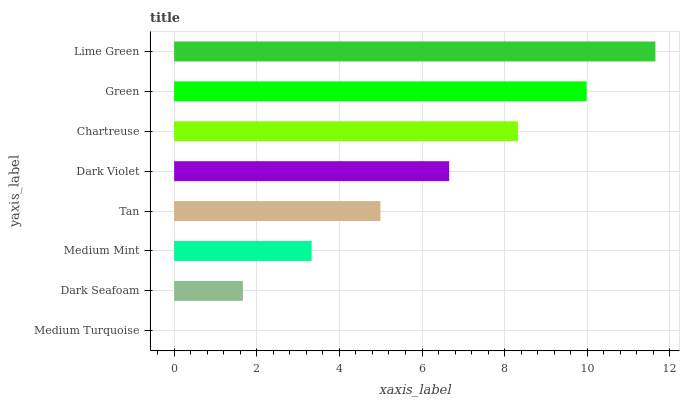Is Medium Turquoise the minimum?
Answer yes or no. Yes. Is Lime Green the maximum?
Answer yes or no. Yes. Is Dark Seafoam the minimum?
Answer yes or no. No. Is Dark Seafoam the maximum?
Answer yes or no. No. Is Dark Seafoam greater than Medium Turquoise?
Answer yes or no. Yes. Is Medium Turquoise less than Dark Seafoam?
Answer yes or no. Yes. Is Medium Turquoise greater than Dark Seafoam?
Answer yes or no. No. Is Dark Seafoam less than Medium Turquoise?
Answer yes or no. No. Is Dark Violet the high median?
Answer yes or no. Yes. Is Tan the low median?
Answer yes or no. Yes. Is Chartreuse the high median?
Answer yes or no. No. Is Medium Mint the low median?
Answer yes or no. No. 